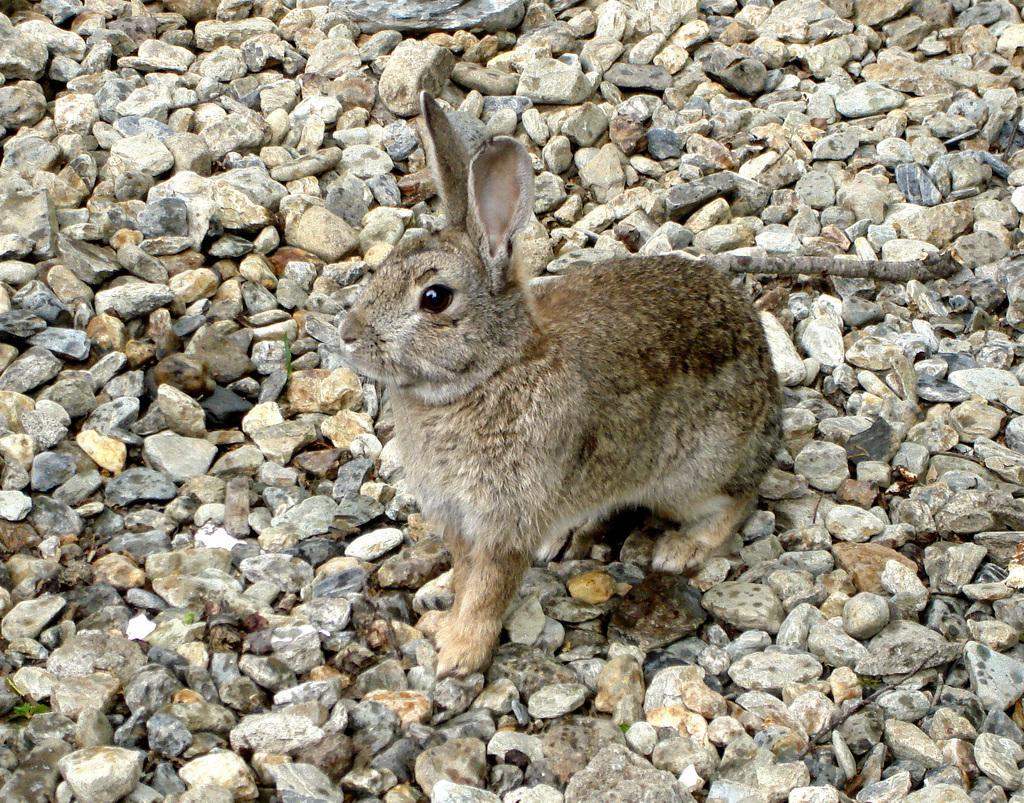In one or two sentences, can you explain what this image depicts? There is a rabbit sitting on the stones and it is of brown color. 